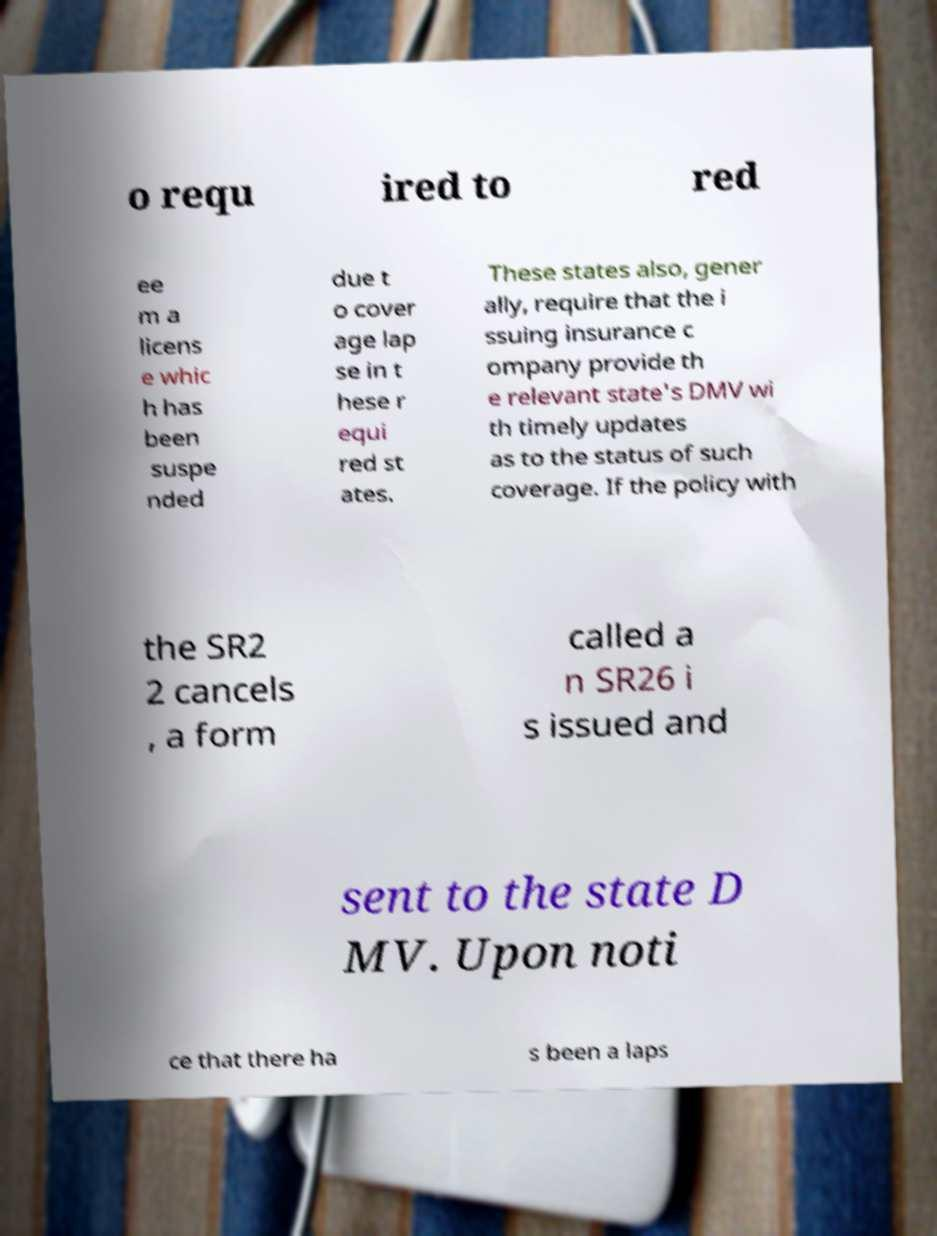Could you extract and type out the text from this image? o requ ired to red ee m a licens e whic h has been suspe nded due t o cover age lap se in t hese r equi red st ates. These states also, gener ally, require that the i ssuing insurance c ompany provide th e relevant state's DMV wi th timely updates as to the status of such coverage. If the policy with the SR2 2 cancels , a form called a n SR26 i s issued and sent to the state D MV. Upon noti ce that there ha s been a laps 